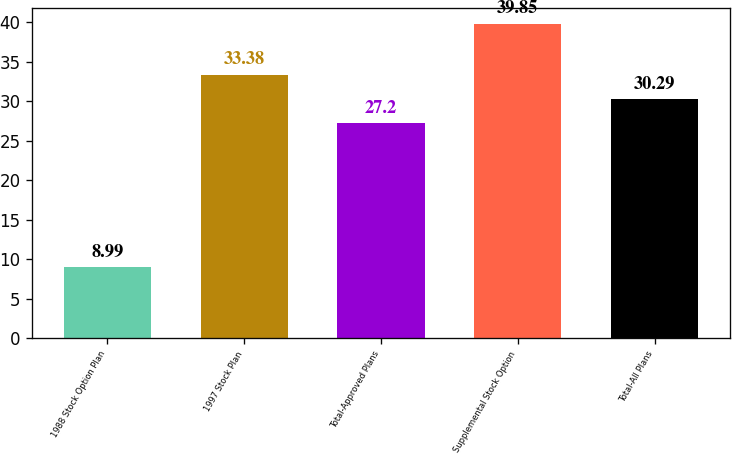<chart> <loc_0><loc_0><loc_500><loc_500><bar_chart><fcel>1988 Stock Option Plan<fcel>1997 Stock Plan<fcel>Total-Approved Plans<fcel>Supplemental Stock Option<fcel>Total-All Plans<nl><fcel>8.99<fcel>33.38<fcel>27.2<fcel>39.85<fcel>30.29<nl></chart> 